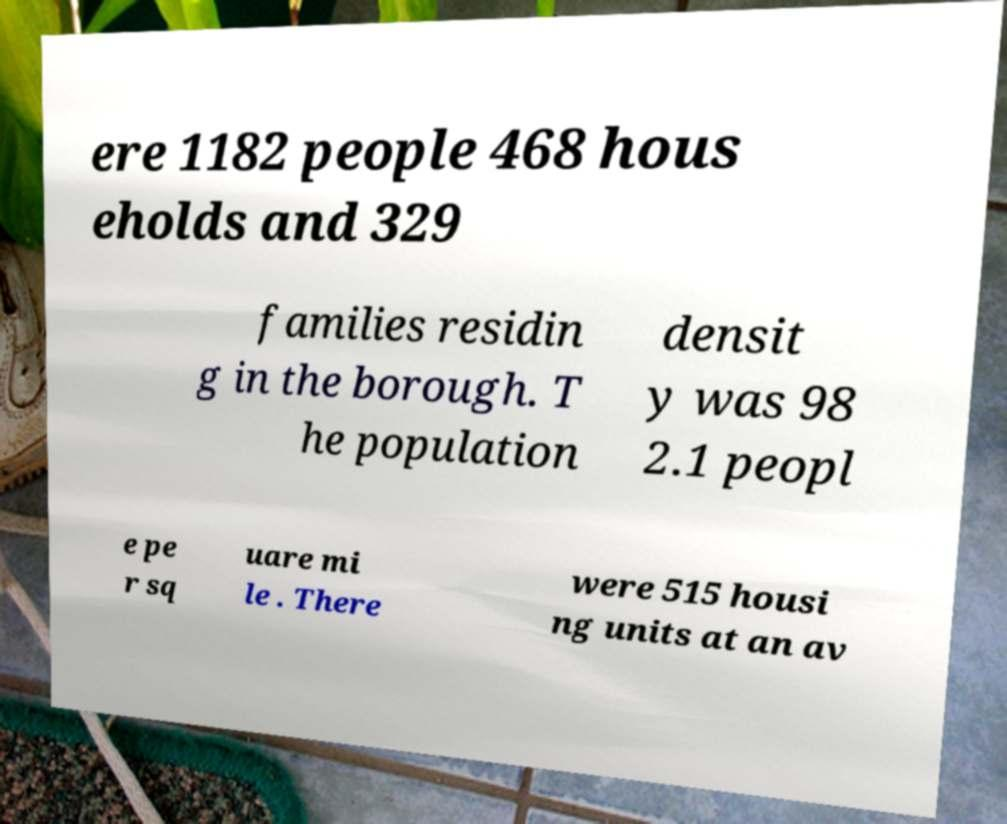What messages or text are displayed in this image? I need them in a readable, typed format. ere 1182 people 468 hous eholds and 329 families residin g in the borough. T he population densit y was 98 2.1 peopl e pe r sq uare mi le . There were 515 housi ng units at an av 